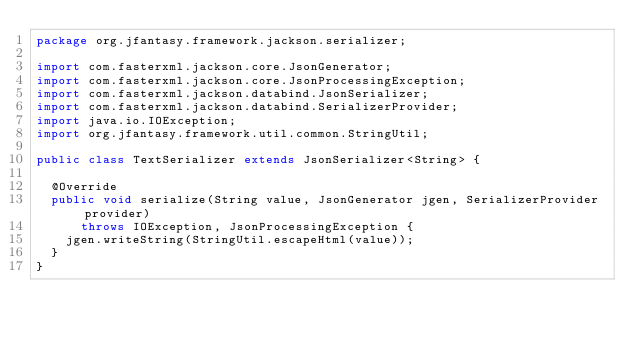<code> <loc_0><loc_0><loc_500><loc_500><_Java_>package org.jfantasy.framework.jackson.serializer;

import com.fasterxml.jackson.core.JsonGenerator;
import com.fasterxml.jackson.core.JsonProcessingException;
import com.fasterxml.jackson.databind.JsonSerializer;
import com.fasterxml.jackson.databind.SerializerProvider;
import java.io.IOException;
import org.jfantasy.framework.util.common.StringUtil;

public class TextSerializer extends JsonSerializer<String> {

  @Override
  public void serialize(String value, JsonGenerator jgen, SerializerProvider provider)
      throws IOException, JsonProcessingException {
    jgen.writeString(StringUtil.escapeHtml(value));
  }
}
</code> 